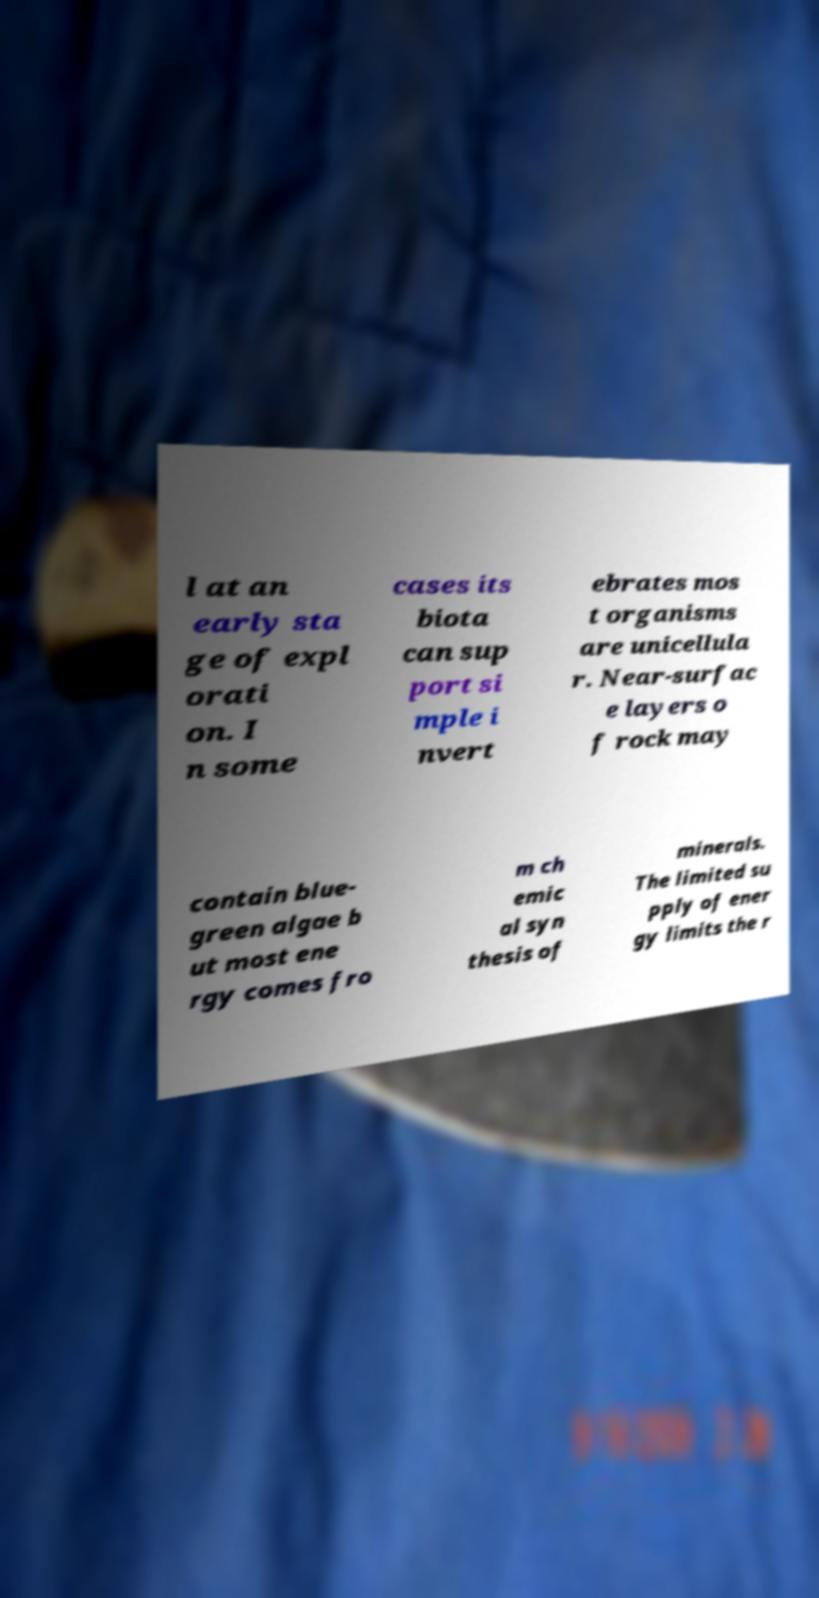I need the written content from this picture converted into text. Can you do that? l at an early sta ge of expl orati on. I n some cases its biota can sup port si mple i nvert ebrates mos t organisms are unicellula r. Near-surfac e layers o f rock may contain blue- green algae b ut most ene rgy comes fro m ch emic al syn thesis of minerals. The limited su pply of ener gy limits the r 